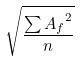Convert formula to latex. <formula><loc_0><loc_0><loc_500><loc_500>\sqrt { \frac { \sum { A _ { f } } ^ { 2 } } { n } }</formula> 